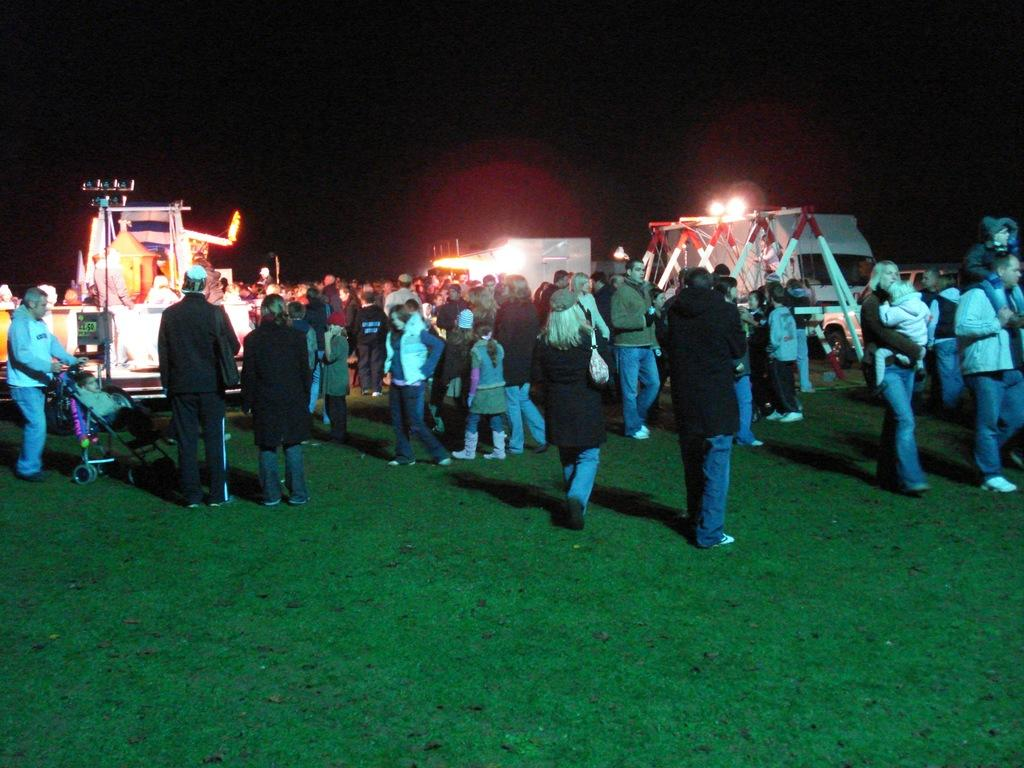How many people are in the image? There is a group of people standing in the image. What else can be seen in the image besides the people? There are vehicles, lights, and other objects in the image. What is the condition of the background in the image? The background of the image is dark. What type of straw is being used by the people in the image? There is no straw present in the image. What season is depicted in the image? The provided facts do not mention any season, and the image does not show any seasonal elements. 